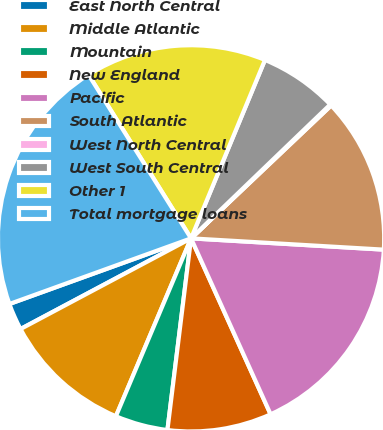Convert chart to OTSL. <chart><loc_0><loc_0><loc_500><loc_500><pie_chart><fcel>East North Central<fcel>Middle Atlantic<fcel>Mountain<fcel>New England<fcel>Pacific<fcel>South Atlantic<fcel>West North Central<fcel>West South Central<fcel>Other 1<fcel>Total mortgage loans<nl><fcel>2.26%<fcel>10.86%<fcel>4.41%<fcel>8.71%<fcel>17.31%<fcel>13.01%<fcel>0.11%<fcel>6.56%<fcel>15.16%<fcel>21.61%<nl></chart> 